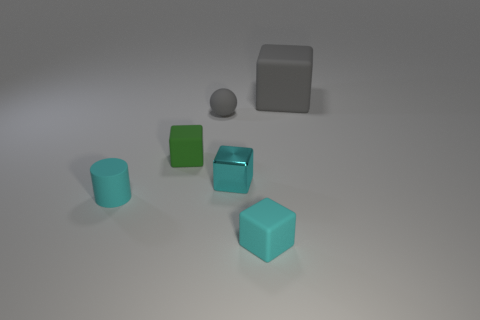The big rubber thing is what color?
Provide a short and direct response. Gray. There is a gray object in front of the big matte cube; what number of green rubber blocks are on the right side of it?
Keep it short and to the point. 0. There is a metallic object; does it have the same size as the gray object on the left side of the large block?
Your answer should be very brief. Yes. Do the metal thing and the gray block have the same size?
Your answer should be very brief. No. Is there a brown thing that has the same size as the cyan metal cube?
Your response must be concise. No. There is a cyan object on the left side of the sphere; what material is it?
Your response must be concise. Rubber. What is the color of the tiny cylinder that is the same material as the small sphere?
Your answer should be very brief. Cyan. What number of shiny objects are big objects or large yellow blocks?
Give a very brief answer. 0. There is a gray matte object that is the same size as the green rubber block; what shape is it?
Your answer should be very brief. Sphere. What number of objects are either green rubber objects that are to the left of the small metal block or matte objects that are to the right of the tiny rubber sphere?
Your answer should be compact. 3. 